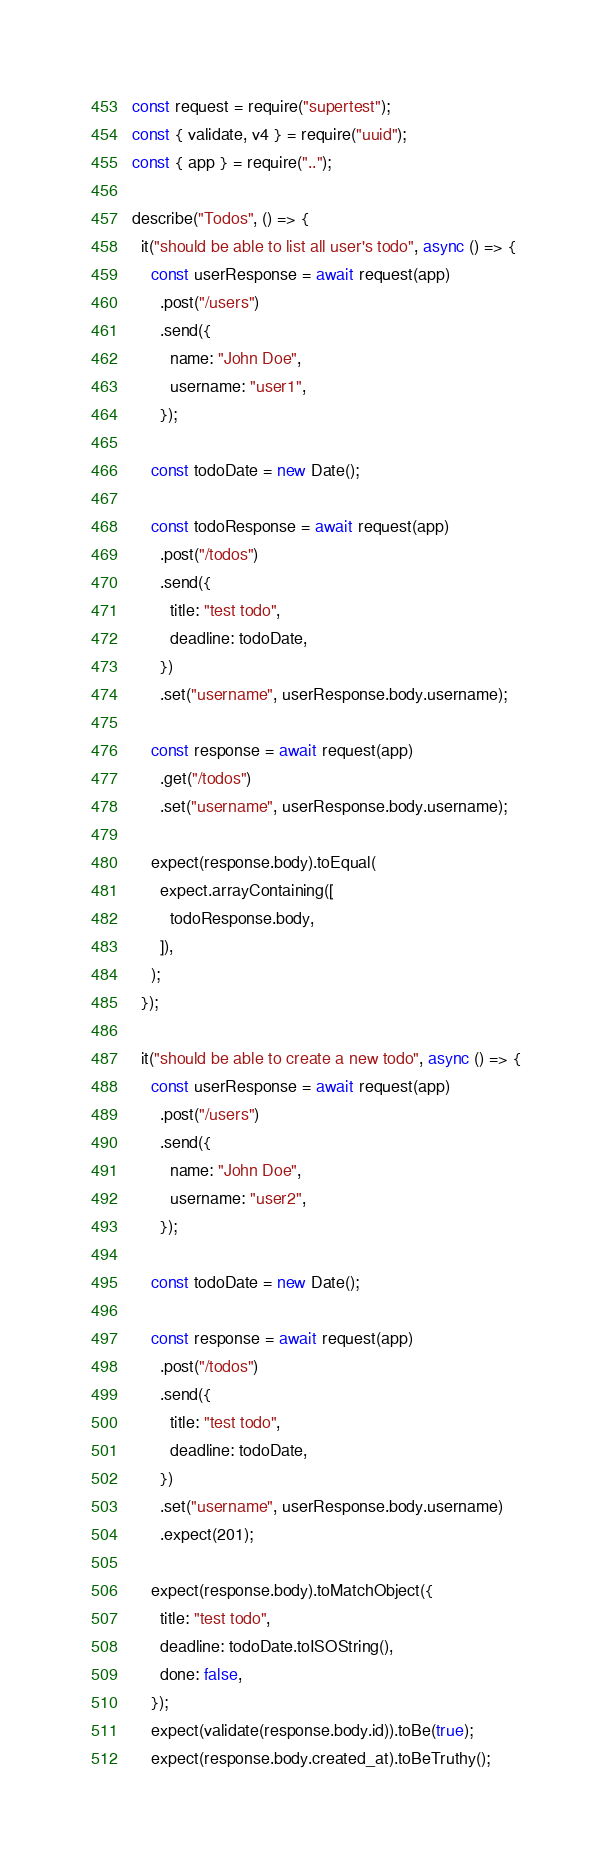<code> <loc_0><loc_0><loc_500><loc_500><_JavaScript_>const request = require("supertest");
const { validate, v4 } = require("uuid");
const { app } = require("..");

describe("Todos", () => {
  it("should be able to list all user's todo", async () => {
    const userResponse = await request(app)
      .post("/users")
      .send({
        name: "John Doe",
        username: "user1",
      });

    const todoDate = new Date();

    const todoResponse = await request(app)
      .post("/todos")
      .send({
        title: "test todo",
        deadline: todoDate,
      })
      .set("username", userResponse.body.username);

    const response = await request(app)
      .get("/todos")
      .set("username", userResponse.body.username);

    expect(response.body).toEqual(
      expect.arrayContaining([
        todoResponse.body,
      ]),
    );
  });

  it("should be able to create a new todo", async () => {
    const userResponse = await request(app)
      .post("/users")
      .send({
        name: "John Doe",
        username: "user2",
      });

    const todoDate = new Date();

    const response = await request(app)
      .post("/todos")
      .send({
        title: "test todo",
        deadline: todoDate,
      })
      .set("username", userResponse.body.username)
      .expect(201);

    expect(response.body).toMatchObject({
      title: "test todo",
      deadline: todoDate.toISOString(),
      done: false,
    });
    expect(validate(response.body.id)).toBe(true);
    expect(response.body.created_at).toBeTruthy();</code> 